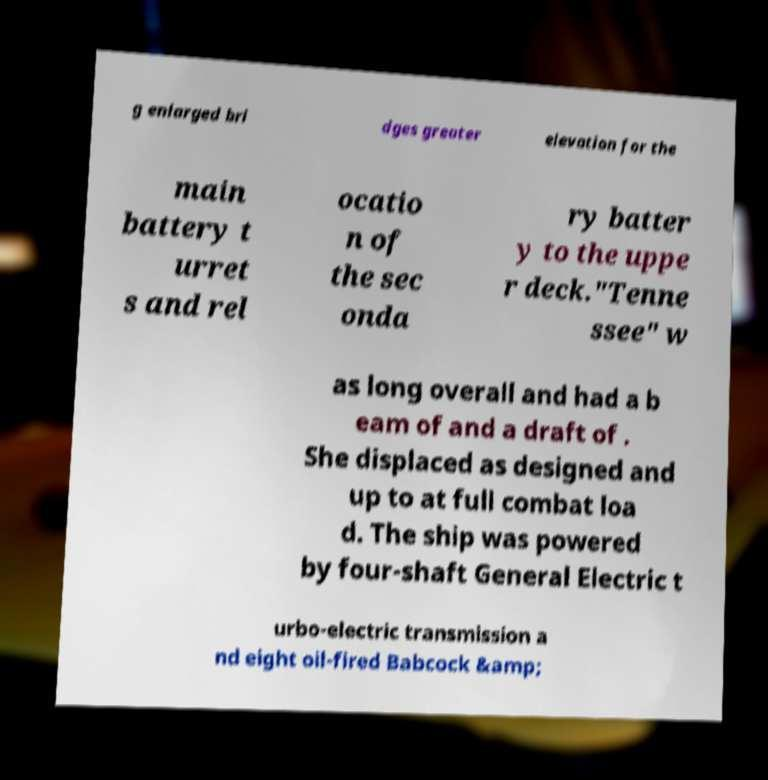Could you extract and type out the text from this image? g enlarged bri dges greater elevation for the main battery t urret s and rel ocatio n of the sec onda ry batter y to the uppe r deck."Tenne ssee" w as long overall and had a b eam of and a draft of . She displaced as designed and up to at full combat loa d. The ship was powered by four-shaft General Electric t urbo-electric transmission a nd eight oil-fired Babcock &amp; 